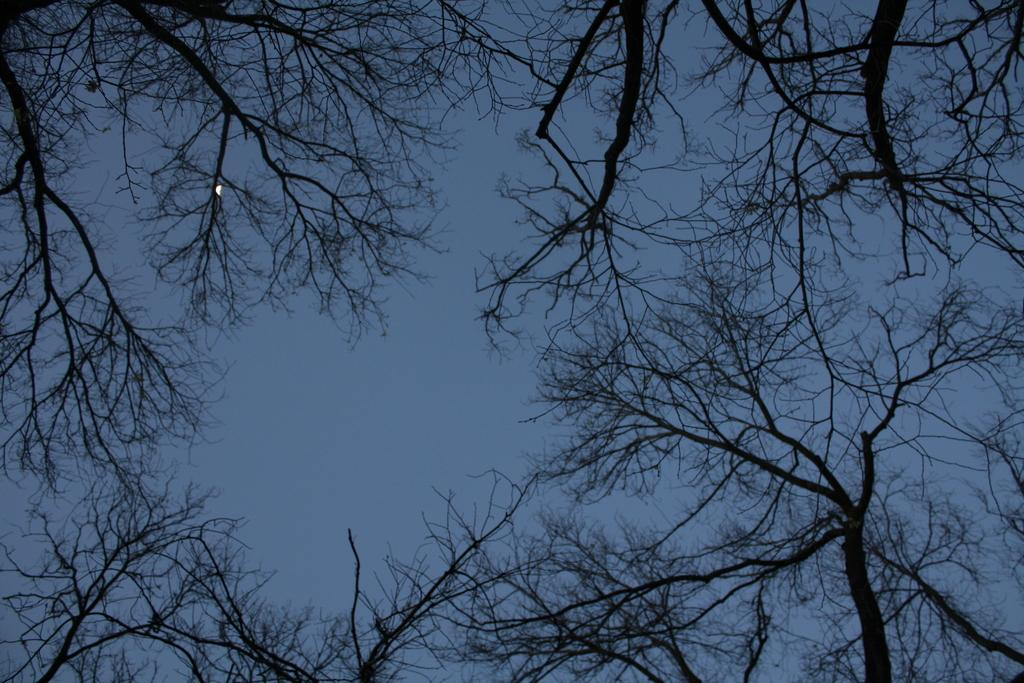What type of natural elements can be seen in the image? There are trees in the image. What part of the natural environment is visible in the image? The sky is visible in the background of the image. Can you describe the object on the left side of the image? There is a white color thing on the left side of the image. What type of organization is depicted in the image? There is no organization depicted in the image; it features trees, sky, and an unspecified white object. Can you tell me how many chains are hanging from the trees in the image? There are no chains present in the image; it features trees, sky, and an unspecified white object. 